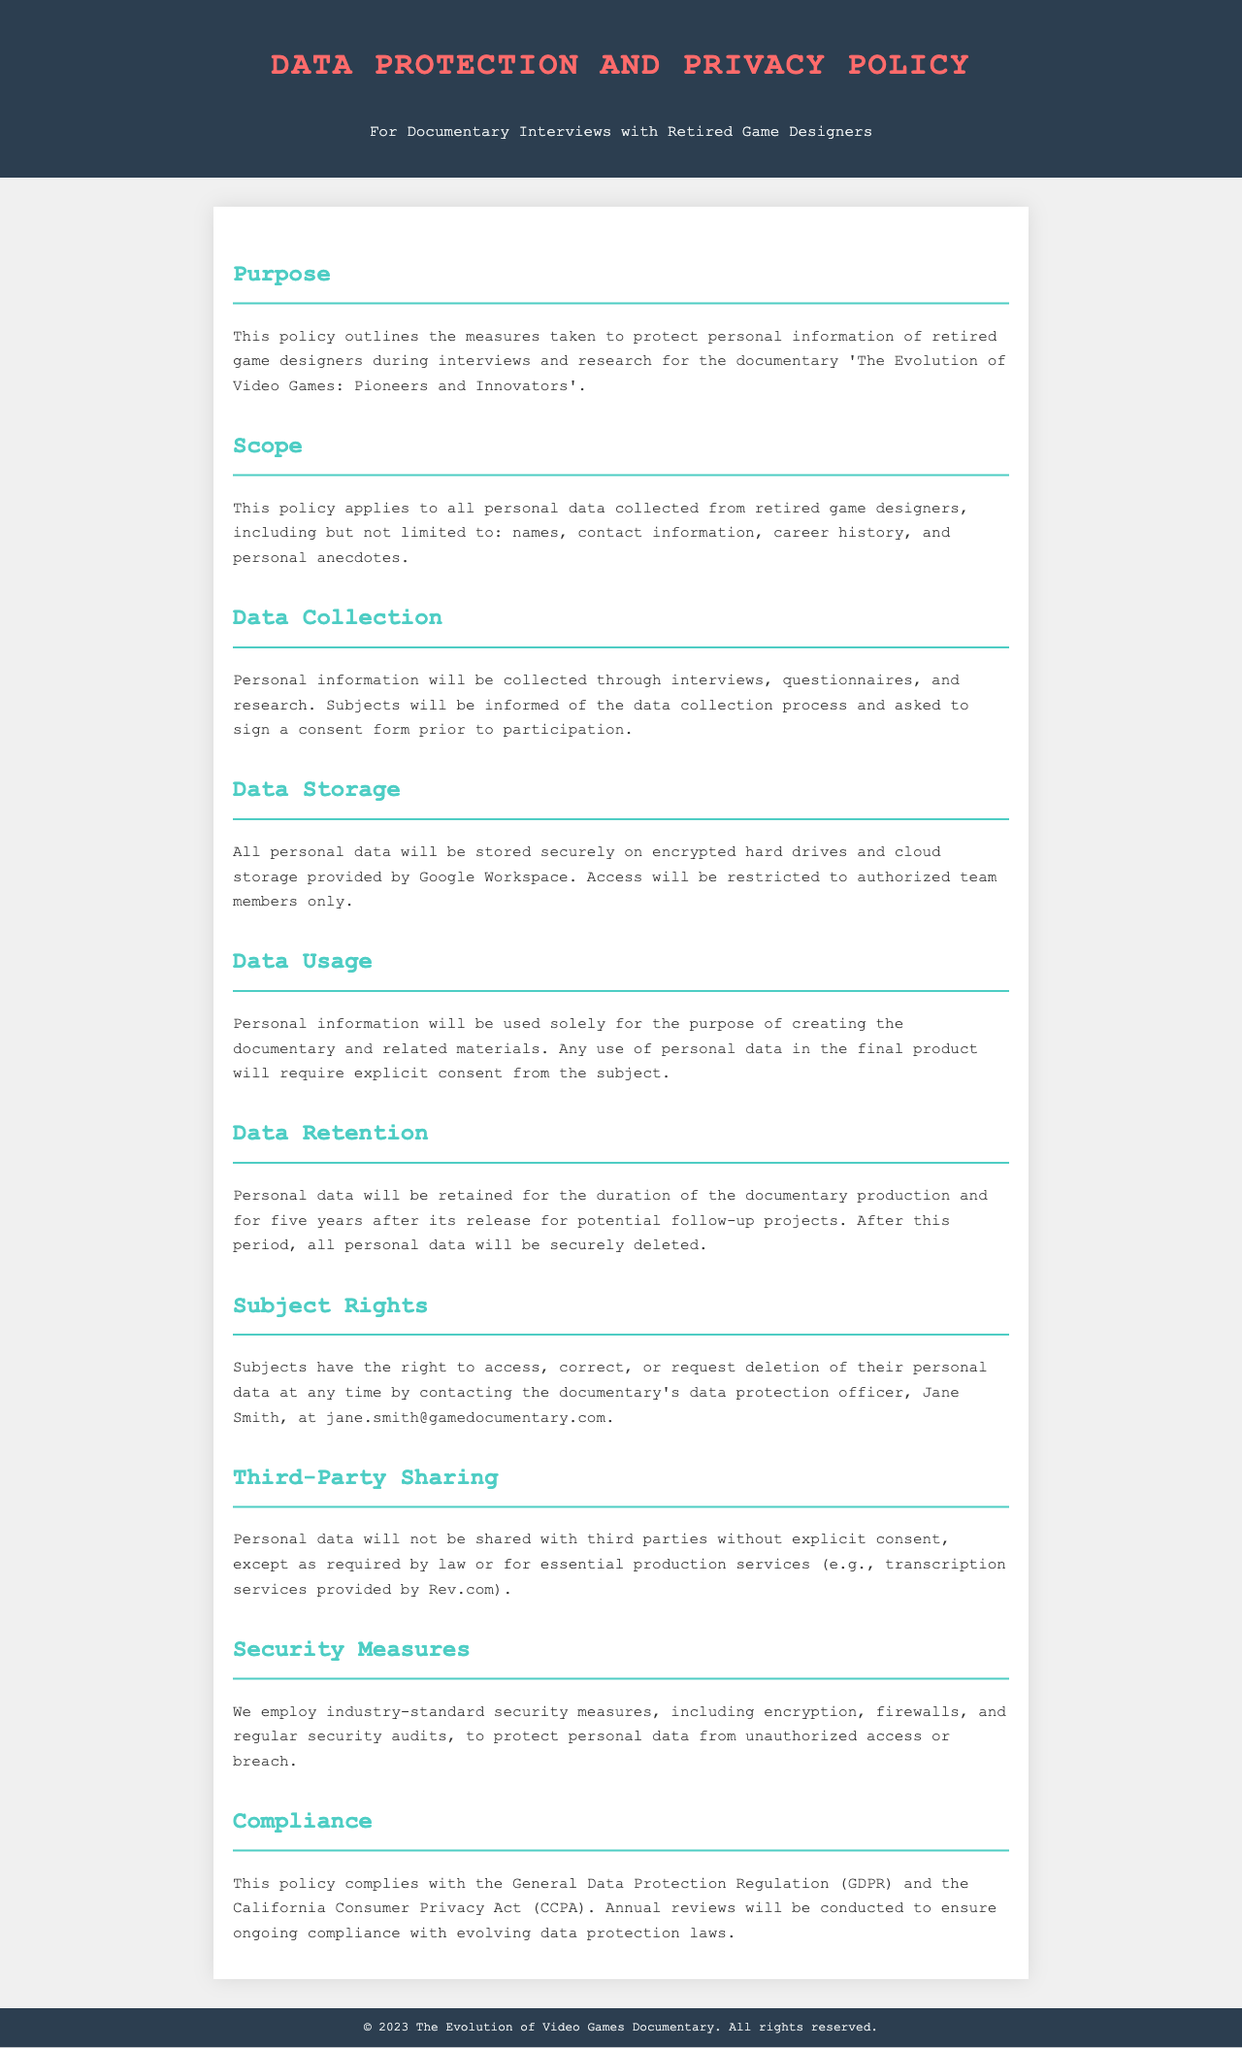What is the title of the documentary? The title of the documentary is mentioned in the purpose section of the document.
Answer: The Evolution of Video Games: Pioneers and Innovators Who is the data protection officer? The name of the data protection officer is provided in the subject rights section of the document.
Answer: Jane Smith How long will personal data be retained after the documentary's release? This information is found in the data retention section, specifying the duration for which personal data will be held.
Answer: Five years What measures are employed to protect personal data? The security measures used to protect personal data are detailed in the security measures section of the document.
Answer: Industry-standard security measures Which laws does this policy comply with? The compliance section lists the laws that this policy adheres to.
Answer: General Data Protection Regulation (GDPR) and California Consumer Privacy Act (CCPA) What type of data will be collected from retired game designers? The scope section specifies the kinds of personal data collected during the research.
Answer: Names, contact information, career history, and personal anecdotes Is consent required for data usage in the final product? The data usage section clarifies the need for consent related to the final product.
Answer: Yes Will personal data be shared with third parties? The third-party sharing section addresses the conditions under which personal data may be shared.
Answer: Not without explicit consent 